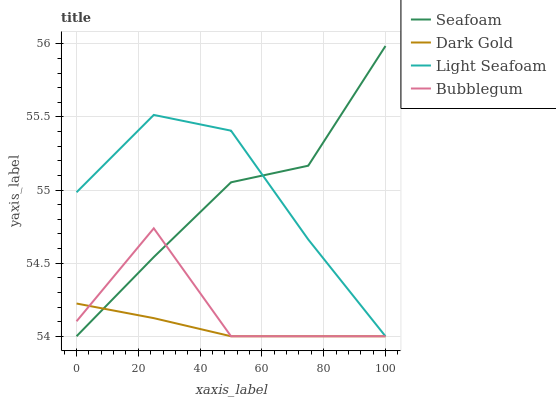Does Dark Gold have the minimum area under the curve?
Answer yes or no. Yes. Does Light Seafoam have the maximum area under the curve?
Answer yes or no. Yes. Does Seafoam have the minimum area under the curve?
Answer yes or no. No. Does Seafoam have the maximum area under the curve?
Answer yes or no. No. Is Dark Gold the smoothest?
Answer yes or no. Yes. Is Bubblegum the roughest?
Answer yes or no. Yes. Is Seafoam the smoothest?
Answer yes or no. No. Is Seafoam the roughest?
Answer yes or no. No. Does Light Seafoam have the lowest value?
Answer yes or no. Yes. Does Seafoam have the highest value?
Answer yes or no. Yes. Does Bubblegum have the highest value?
Answer yes or no. No. Does Dark Gold intersect Bubblegum?
Answer yes or no. Yes. Is Dark Gold less than Bubblegum?
Answer yes or no. No. Is Dark Gold greater than Bubblegum?
Answer yes or no. No. 